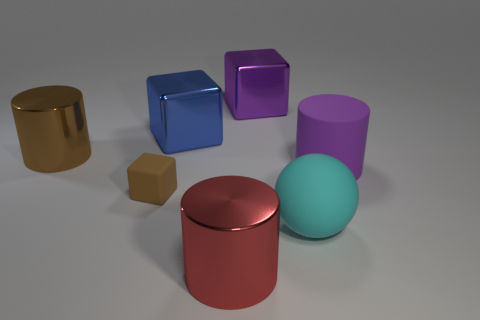Subtract all purple blocks. How many blocks are left? 2 Subtract all large cubes. How many cubes are left? 1 Subtract all cylinders. How many objects are left? 4 Subtract 1 cylinders. How many cylinders are left? 2 Subtract all brown cylinders. Subtract all green spheres. How many cylinders are left? 2 Subtract all green balls. How many cyan cubes are left? 0 Subtract all gray metal spheres. Subtract all large blue cubes. How many objects are left? 6 Add 3 big blue cubes. How many big blue cubes are left? 4 Add 6 large purple matte cylinders. How many large purple matte cylinders exist? 7 Add 2 big blue blocks. How many objects exist? 9 